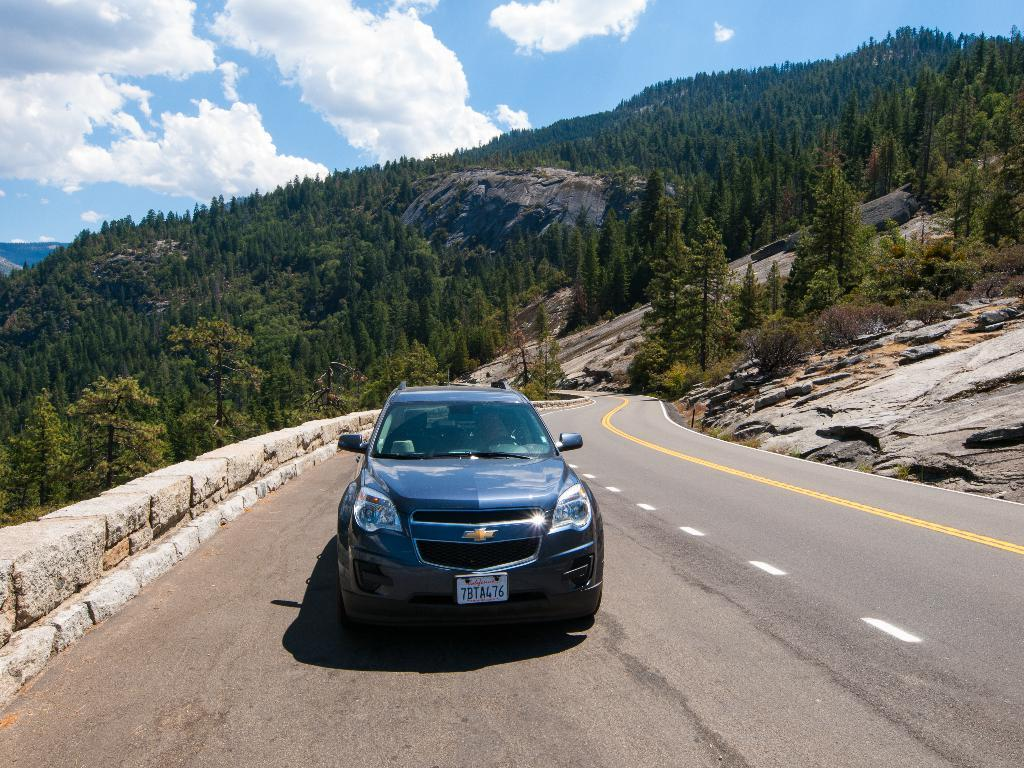What type of natural elements can be seen in the image? There are trees and plants in the image. What man-made object is present in the image? There is a car in the image. What type of pathway is visible in the image? There is a road in the image. What is visible in the background of the image? The sky is visible in the background of the image, and it appears to be cloudy. What time of day is it in the image, based on the hour shown on the sheet? There is no sheet or indication of time in the image, so it cannot be determined from the image. 